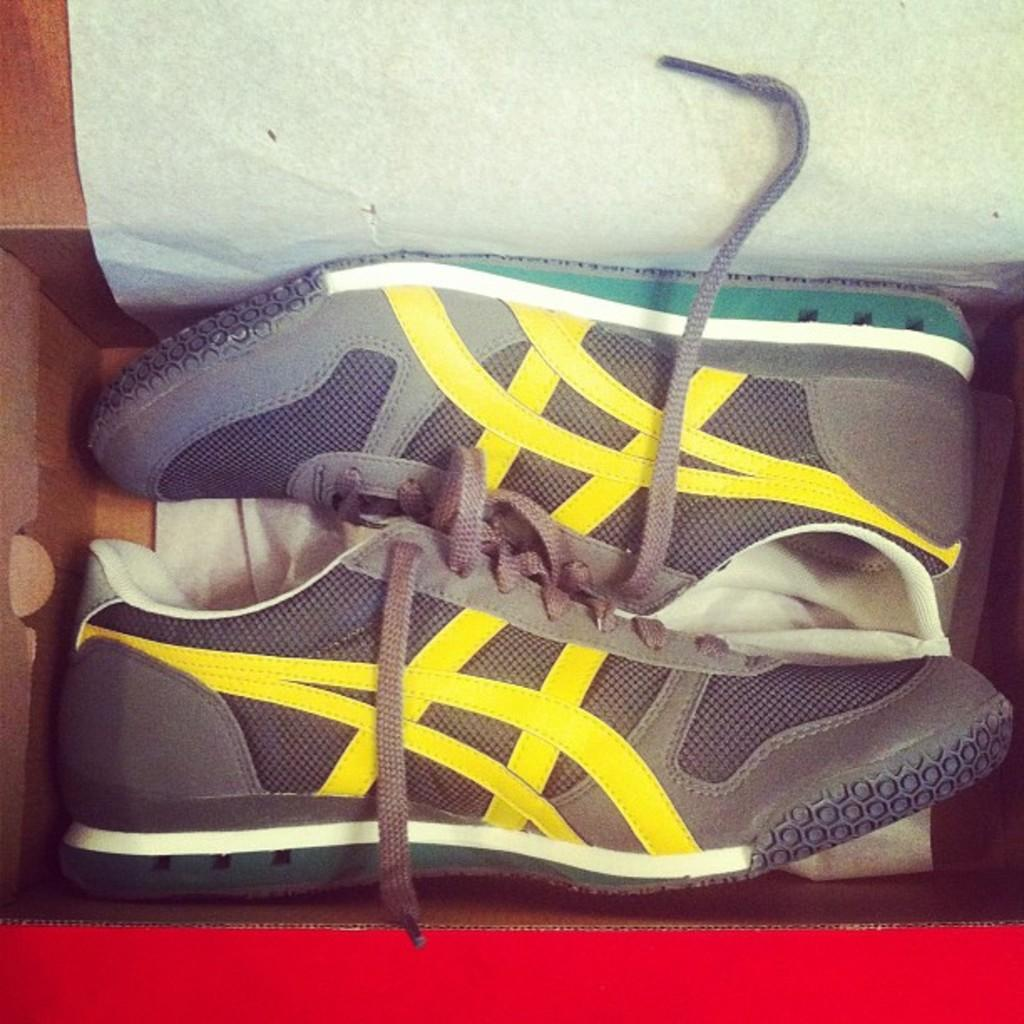What is in the box that is visible in the image? There is a pair of shoes in the box. What is the condition of the shoes in the image? The shoes are in a box. What else can be seen beside the shoes in the image? There is a paper beside the shoes. How does the sneeze affect the transportation of the shoes in the image? There is no sneeze or transportation of the shoes in the image; it simply shows a pair of shoes in a box with a paper beside them. 